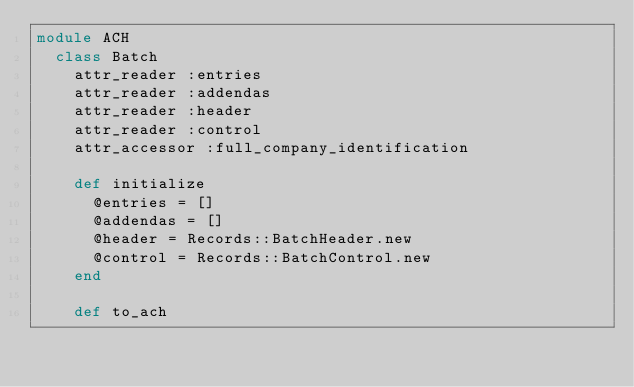<code> <loc_0><loc_0><loc_500><loc_500><_Ruby_>module ACH
  class Batch
    attr_reader :entries
    attr_reader :addendas
    attr_reader :header
    attr_reader :control
    attr_accessor :full_company_identification

    def initialize
      @entries = []
      @addendas = []
      @header = Records::BatchHeader.new
      @control = Records::BatchControl.new
    end

    def to_ach</code> 